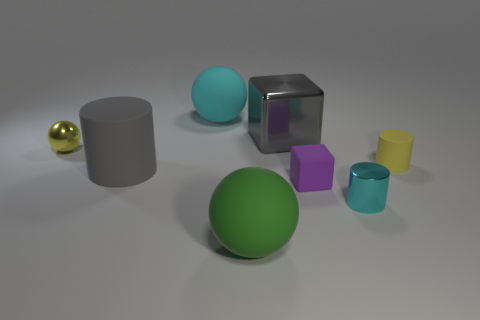There is a large object that is the same color as the metallic cube; what shape is it?
Keep it short and to the point. Cylinder. What number of other things are the same material as the small yellow sphere?
Provide a short and direct response. 2. Does the small rubber block have the same color as the shiny ball?
Your answer should be very brief. No. Are there fewer yellow spheres that are on the right side of the gray matte object than yellow spheres that are behind the big gray cube?
Your answer should be compact. No. What color is the other matte object that is the same shape as the big green object?
Offer a terse response. Cyan. There is a cyan thing that is right of the purple object; is its size the same as the big metal block?
Give a very brief answer. No. Are there fewer gray rubber cylinders to the left of the metal sphere than large cyan balls?
Provide a short and direct response. Yes. Is there any other thing that is the same size as the metallic sphere?
Give a very brief answer. Yes. There is a yellow thing left of the cyan object that is behind the gray matte cylinder; what size is it?
Provide a succinct answer. Small. Is there any other thing that is the same shape as the cyan matte thing?
Keep it short and to the point. Yes. 